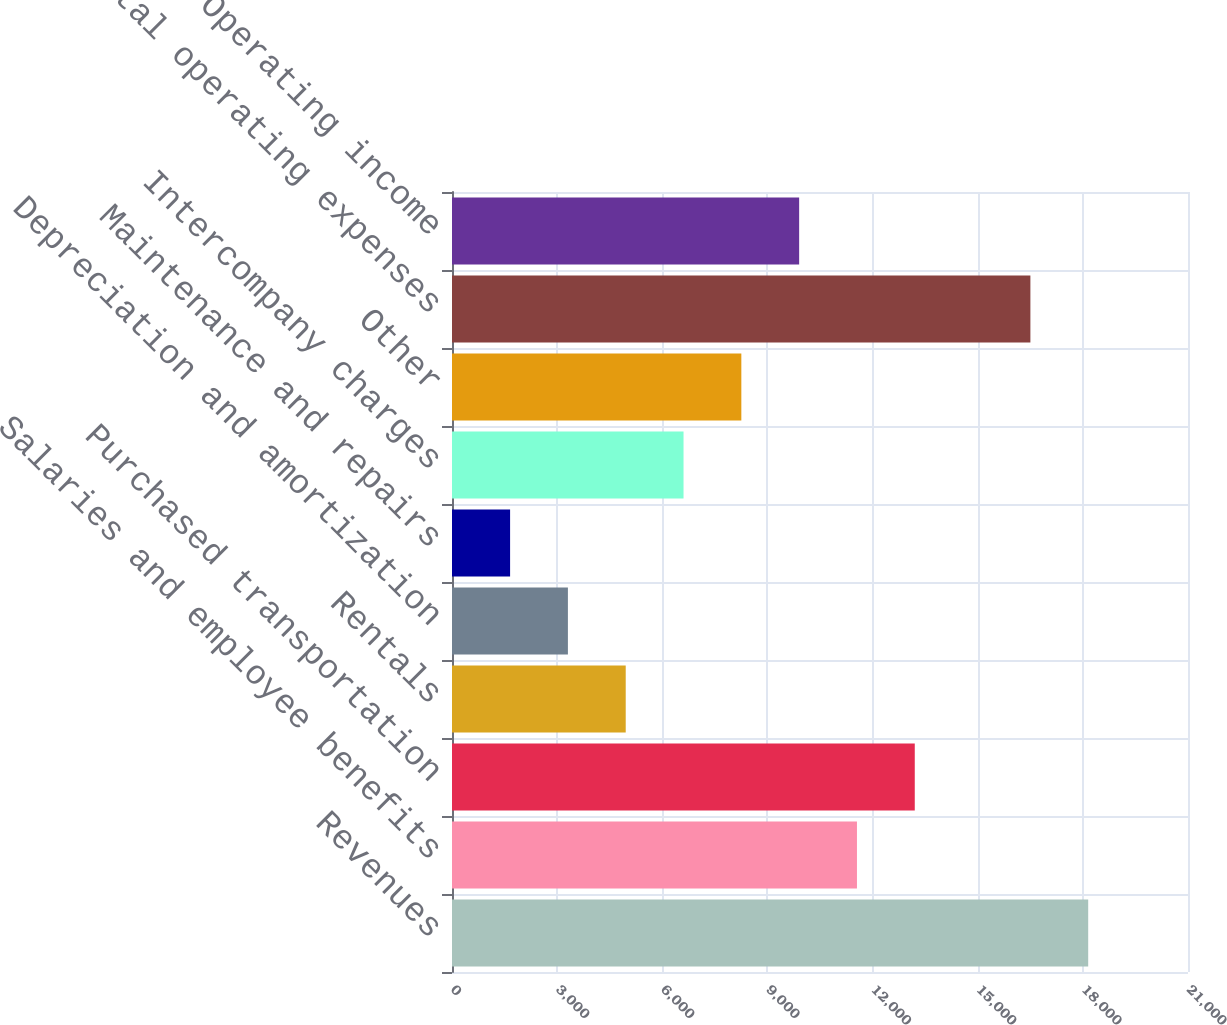<chart> <loc_0><loc_0><loc_500><loc_500><bar_chart><fcel>Revenues<fcel>Salaries and employee benefits<fcel>Purchased transportation<fcel>Rentals<fcel>Depreciation and amortization<fcel>Maintenance and repairs<fcel>Intercompany charges<fcel>Other<fcel>Total operating expenses<fcel>Operating income<nl><fcel>18152.5<fcel>11554.5<fcel>13204<fcel>4956.62<fcel>3307.14<fcel>1657.66<fcel>6606.1<fcel>8255.58<fcel>16503<fcel>9905.06<nl></chart> 